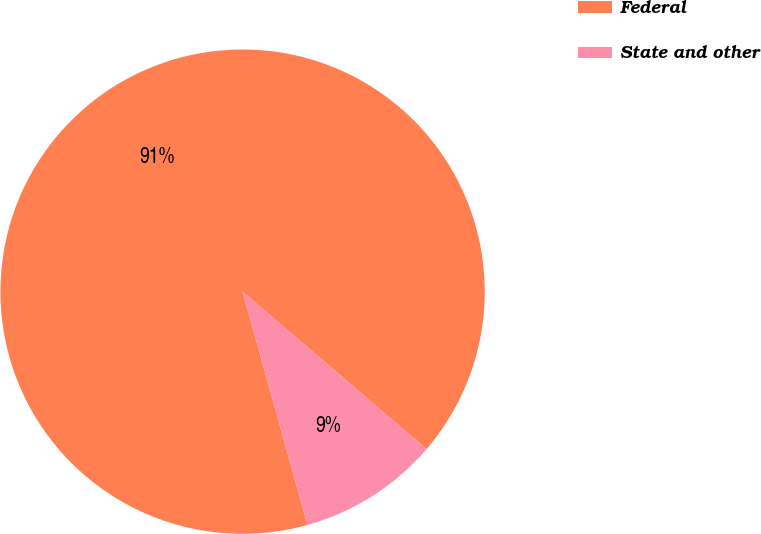Convert chart. <chart><loc_0><loc_0><loc_500><loc_500><pie_chart><fcel>Federal<fcel>State and other<nl><fcel>90.59%<fcel>9.41%<nl></chart> 